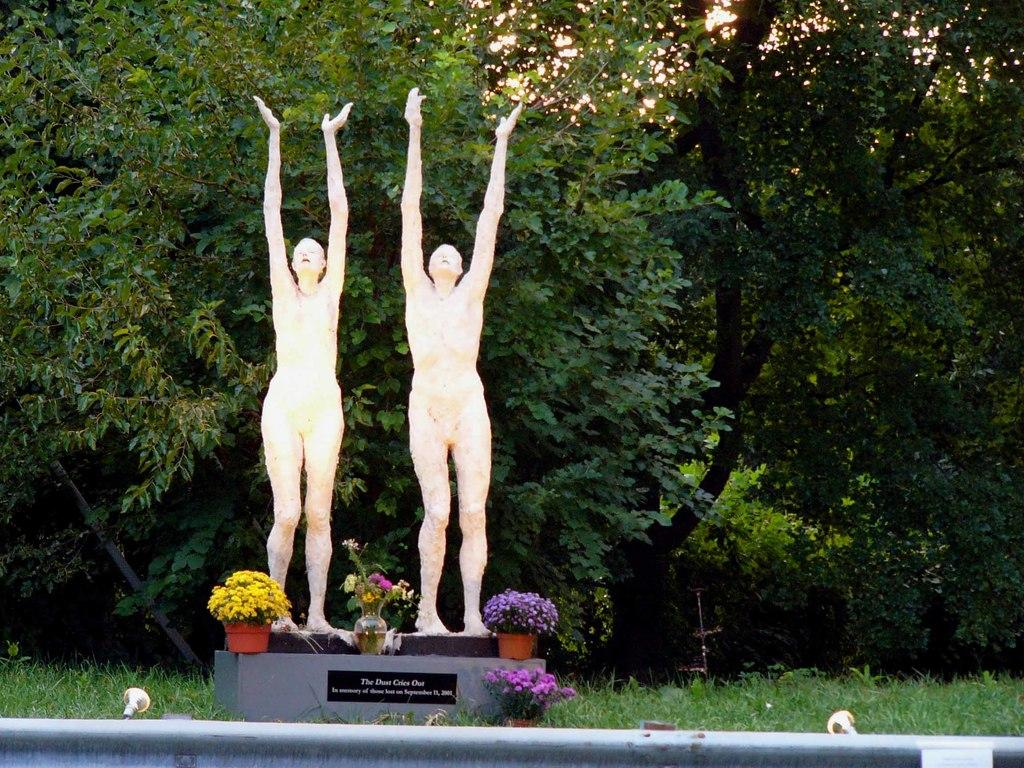How many people are present in the image? There are two persons standing in the image. What type of natural elements can be seen in the image? There are trees and plants in the image. What type of government is depicted in the image? There is no depiction of a government in the image; it features two persons and natural elements. 